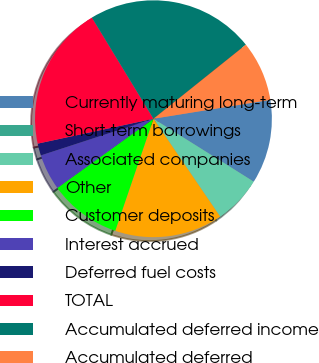<chart> <loc_0><loc_0><loc_500><loc_500><pie_chart><fcel>Currently maturing long-term<fcel>Short-term borrowings<fcel>Associated companies<fcel>Other<fcel>Customer deposits<fcel>Interest accrued<fcel>Deferred fuel costs<fcel>TOTAL<fcel>Accumulated deferred income<fcel>Accumulated deferred<nl><fcel>11.47%<fcel>0.0%<fcel>6.56%<fcel>14.75%<fcel>9.84%<fcel>4.92%<fcel>1.64%<fcel>19.67%<fcel>22.95%<fcel>8.2%<nl></chart> 